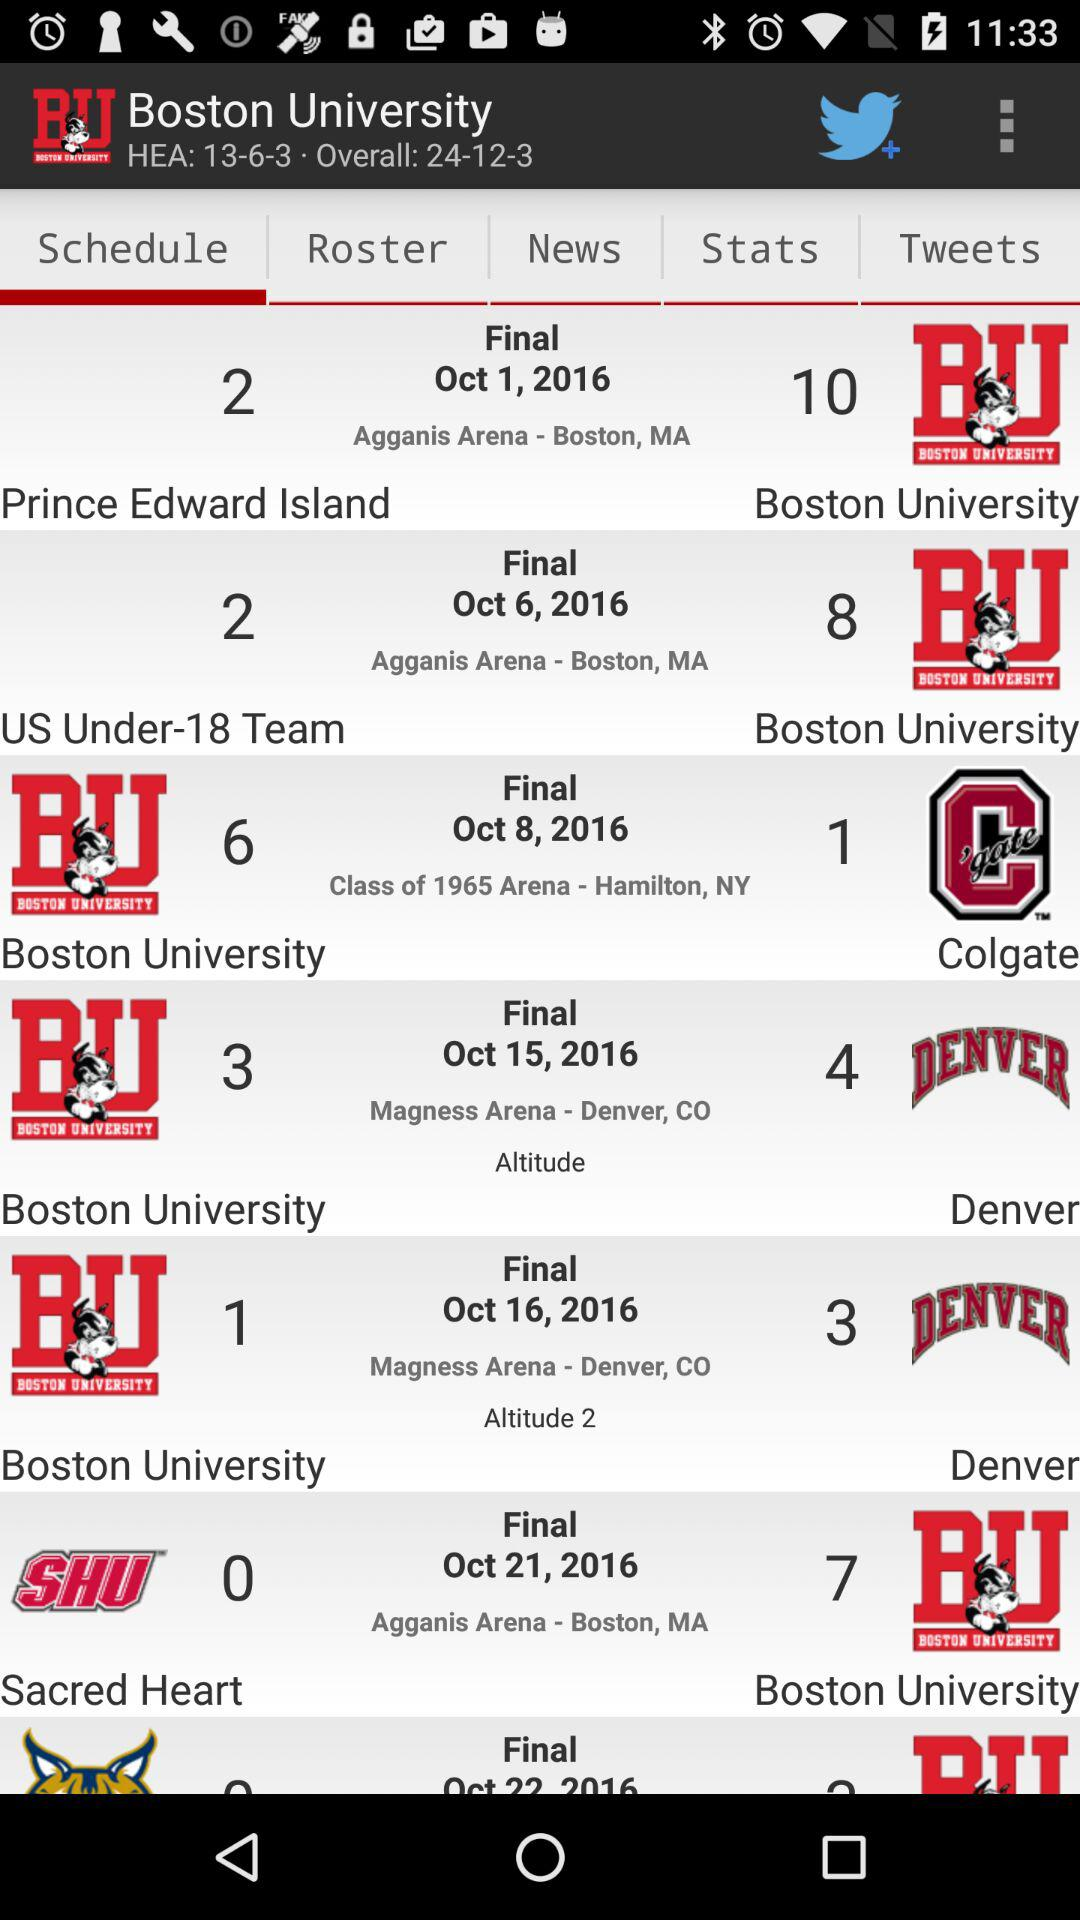What is the final date for Boston University?
When the provided information is insufficient, respond with <no answer>. <no answer> 